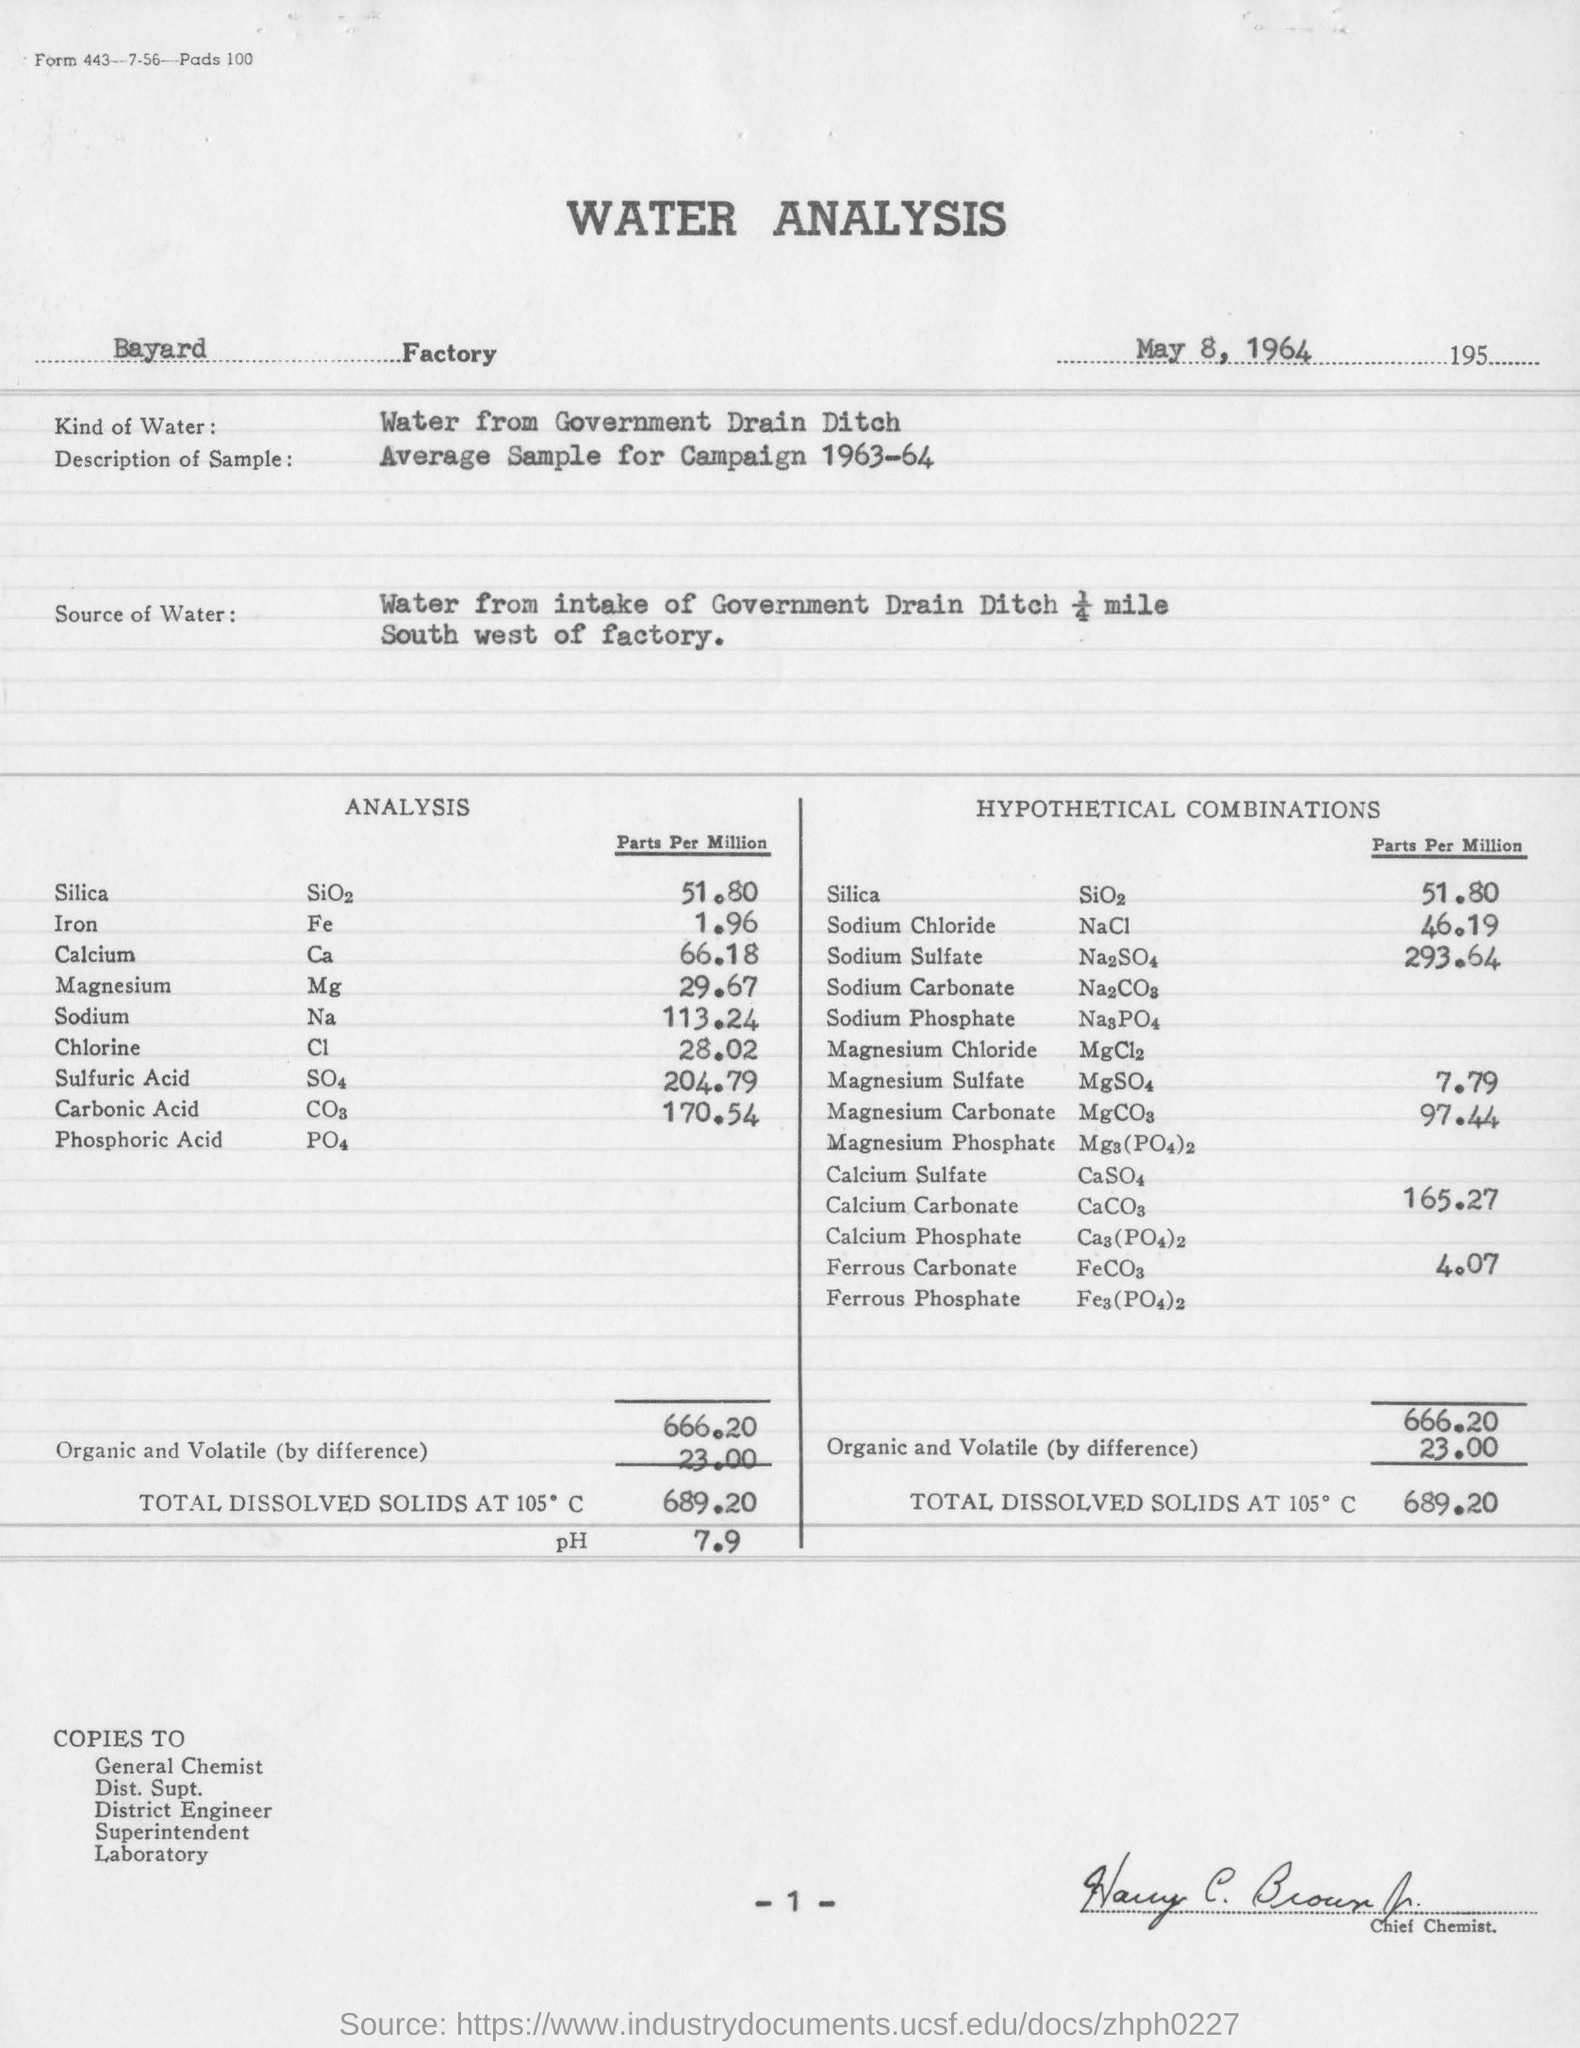Identify some key points in this picture. The analysis was done on May 8, 1964. The hypothetical combination of sodium sulfate is 293.64 parts per million. The pH value of total dissolved solids at 105 degrees Celsius is 7.9. The Bayard factory is the name of the factory. The amount of total dissolved solids at 105 degrees Celsius is 689.20 milligrams per liter. 